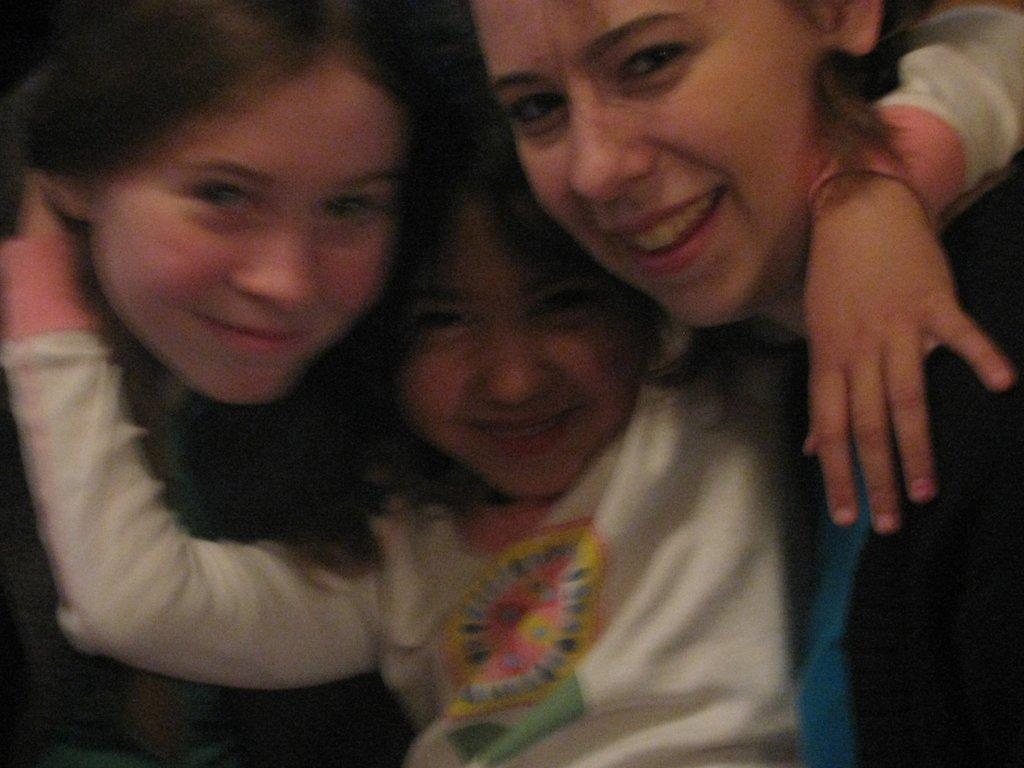Describe this image in one or two sentences. In the image there is a kid in the middle holding two women on either side of her, she is wearing white t-shirt. 